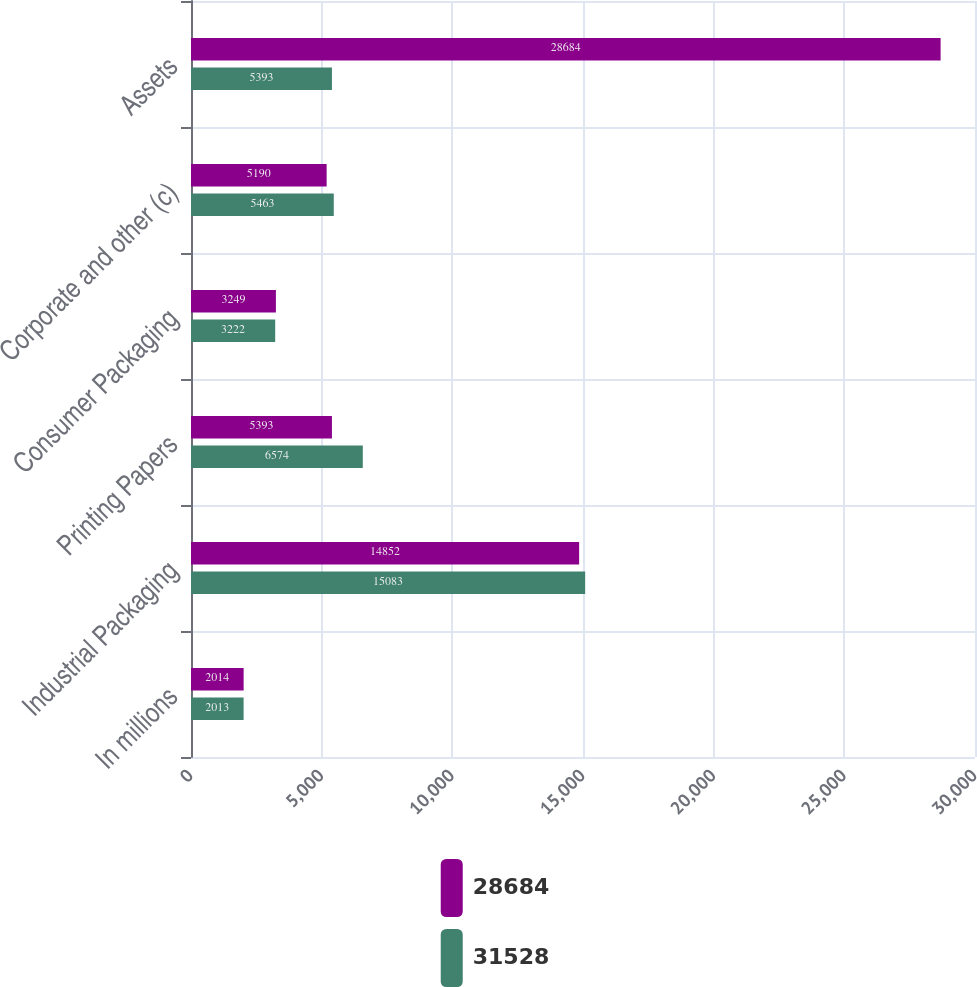Convert chart to OTSL. <chart><loc_0><loc_0><loc_500><loc_500><stacked_bar_chart><ecel><fcel>In millions<fcel>Industrial Packaging<fcel>Printing Papers<fcel>Consumer Packaging<fcel>Corporate and other (c)<fcel>Assets<nl><fcel>28684<fcel>2014<fcel>14852<fcel>5393<fcel>3249<fcel>5190<fcel>28684<nl><fcel>31528<fcel>2013<fcel>15083<fcel>6574<fcel>3222<fcel>5463<fcel>5393<nl></chart> 